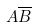Convert formula to latex. <formula><loc_0><loc_0><loc_500><loc_500>A \overline { B }</formula> 